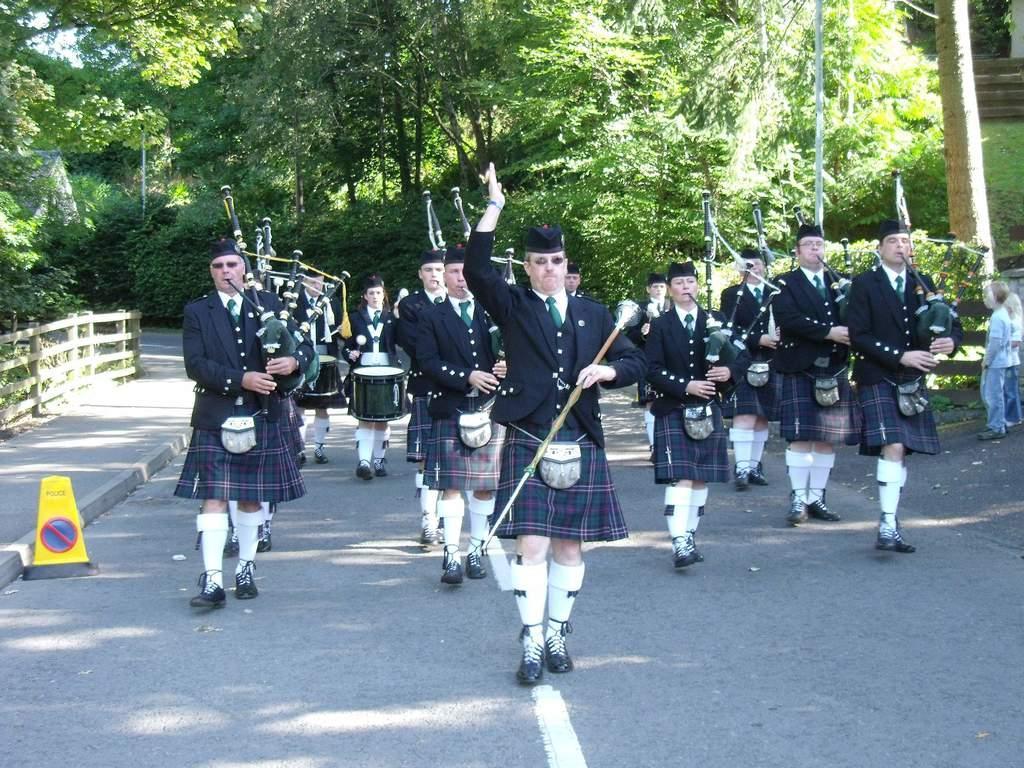Could you give a brief overview of what you see in this image? In this picture there are group of people, those who are performing the parade in a different queues there are trees around the area of the image and there are two children those who are standing at the right side of the image, and the whole group is in a same dress code there are stairs at the top right side of the image. 